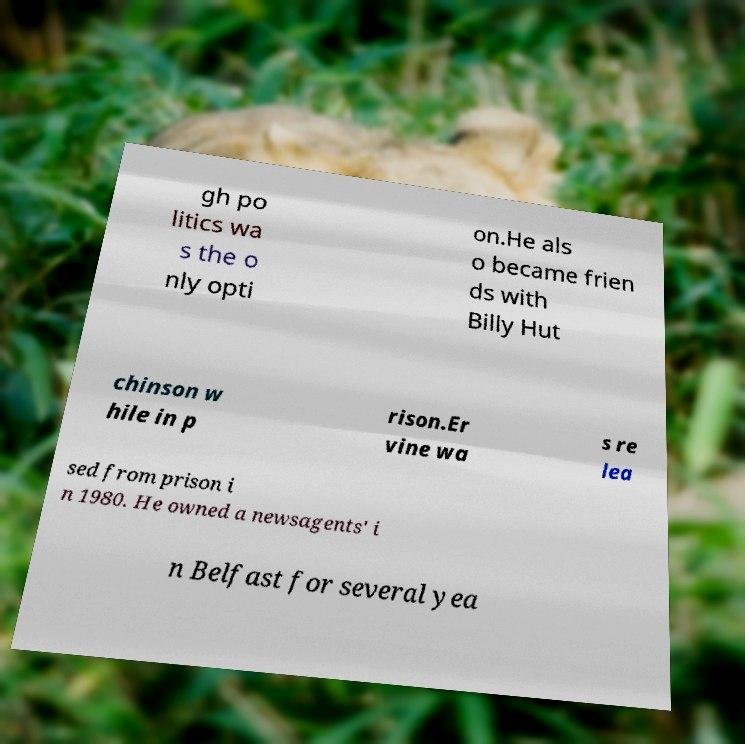Can you read and provide the text displayed in the image?This photo seems to have some interesting text. Can you extract and type it out for me? gh po litics wa s the o nly opti on.He als o became frien ds with Billy Hut chinson w hile in p rison.Er vine wa s re lea sed from prison i n 1980. He owned a newsagents' i n Belfast for several yea 